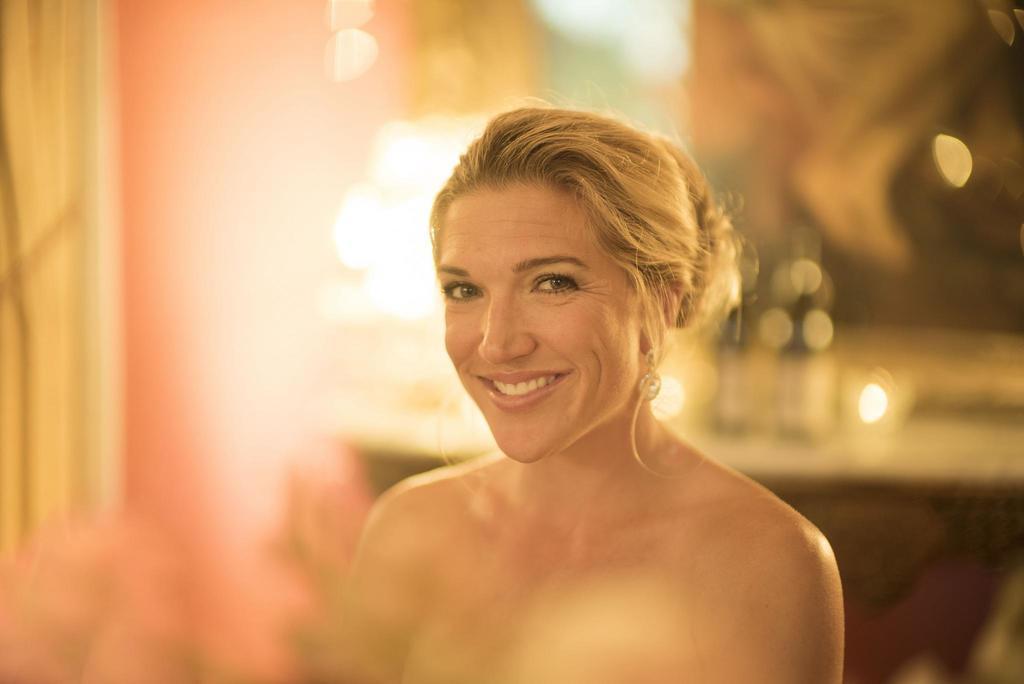Can you describe this image briefly? In this image there is a lady with smiling face. The background is blurry. 